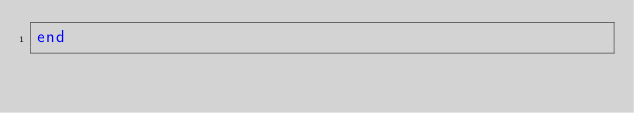<code> <loc_0><loc_0><loc_500><loc_500><_Ruby_>end
</code> 